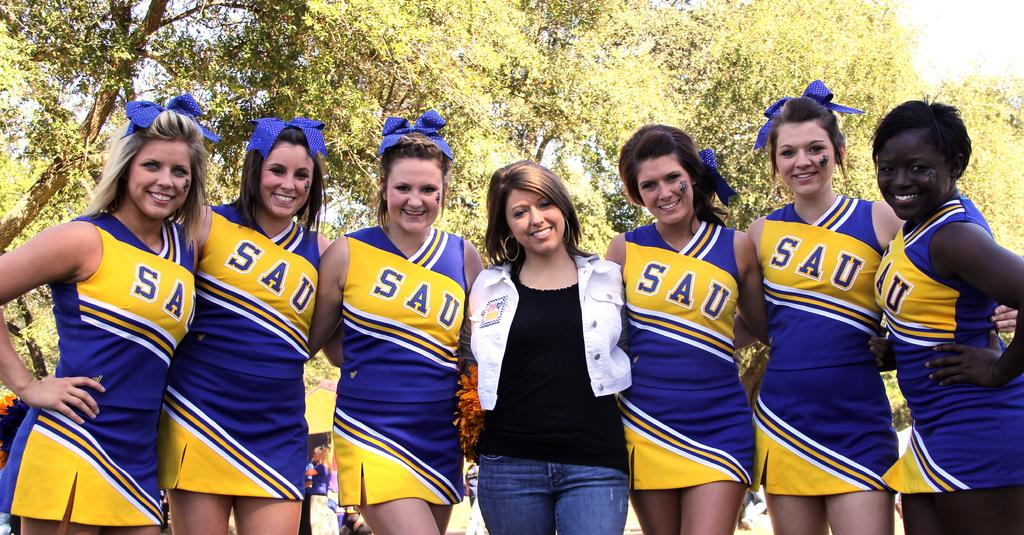<image>
Offer a succinct explanation of the picture presented. A group of cheerleaders with SAU on the front. 